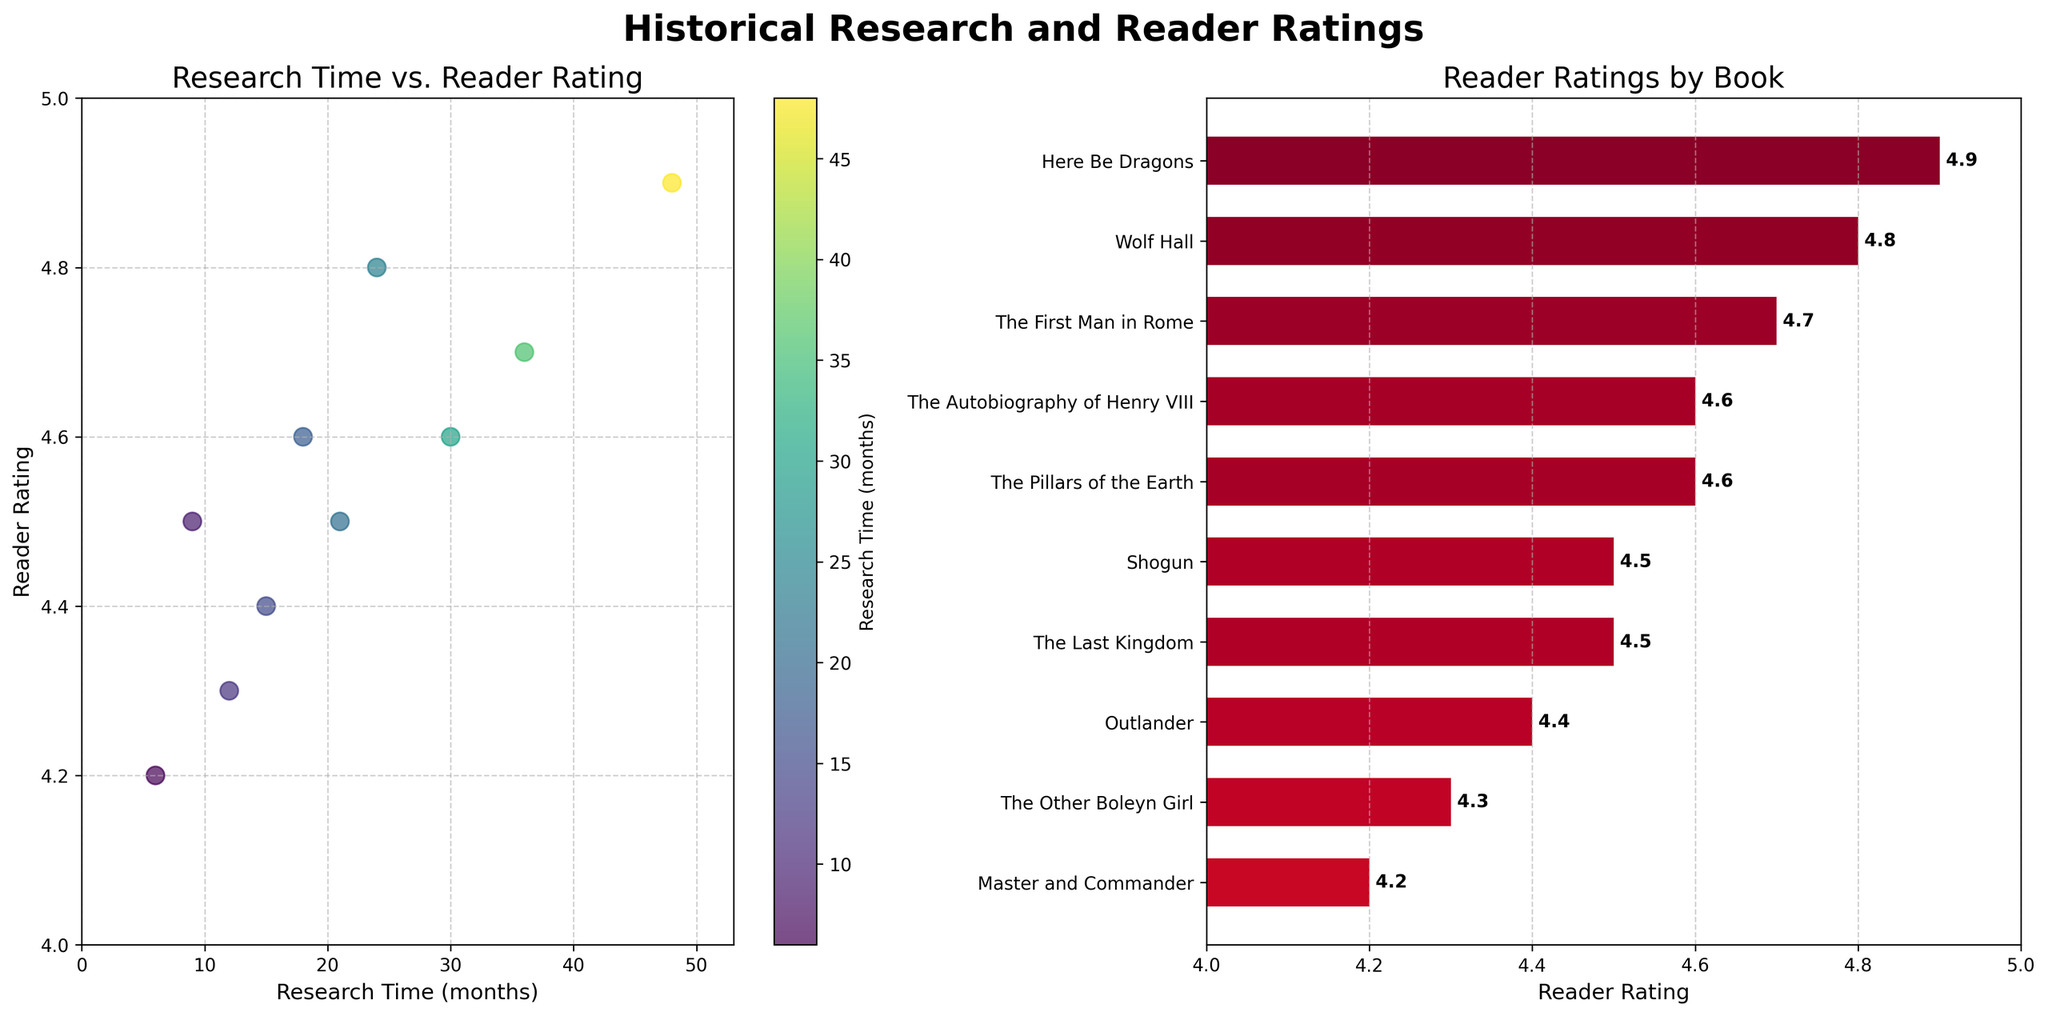What is the title of the first subplot? Look at the title above the first subplot in the figure; it reads "Research Time vs. Reader Rating".
Answer: Research Time vs. Reader Rating What is the X-axis label for the scatter plot? Refer to the label along the X-axis of the first subplot to see which variable it represents. It is labeled "Research Time (months)".
Answer: Research Time (months) How many books have a reader rating above 4.6? Identify the books in the scatter plot and bar plot with reader ratings above 4.6. There are four such books: "Wolf Hall", "The First Man in Rome", "The Autobiography of Henry VIII", and "Here Be Dragons".
Answer: Four Which book has the highest reader rating, and what is its rating? Check the highest data point on both subplots. "Here Be Dragons" has the highest rating of 4.9, which is also confirmed in the bar plot.
Answer: Here Be Dragons with a rating of 4.9 Compare the research time for "Shogun" and "Master and Commander". Which one has a longer research time? "Shogun" plotted on the scatter plot has a research time of 21 months, while "Master and Commander" has a research time of 6 months.
Answer: Shogun What is the overall trend between research time and reader rating in the scatter plot? Observe the pattern of data points in the scatter plot. There is a general trend where longer research times tend to correlate with higher reader ratings.
Answer: Longer research time correlates with higher ratings What book has the lowest reader rating, and what is its research time? Identify the lowest rating in the bar plot and determine the corresponding book and research time. "Master and Commander" has the lowest rating of 4.2 with a research time of 6 months.
Answer: Master and Commander with a research time of 6 months What is the average research time for all the books in the dataset? Add up all the research times and divide by the number of books (21+36+30+18+12+9+24+48+15+6 = 216 months; 216/10 = 21.6 months).
Answer: 21.6 months Which time period is most frequently represented in the dataset, based on the bar plot labels? Check the time periods associated with each book title in the bar plot. "Tudor England" appears three times.
Answer: Tudor England 